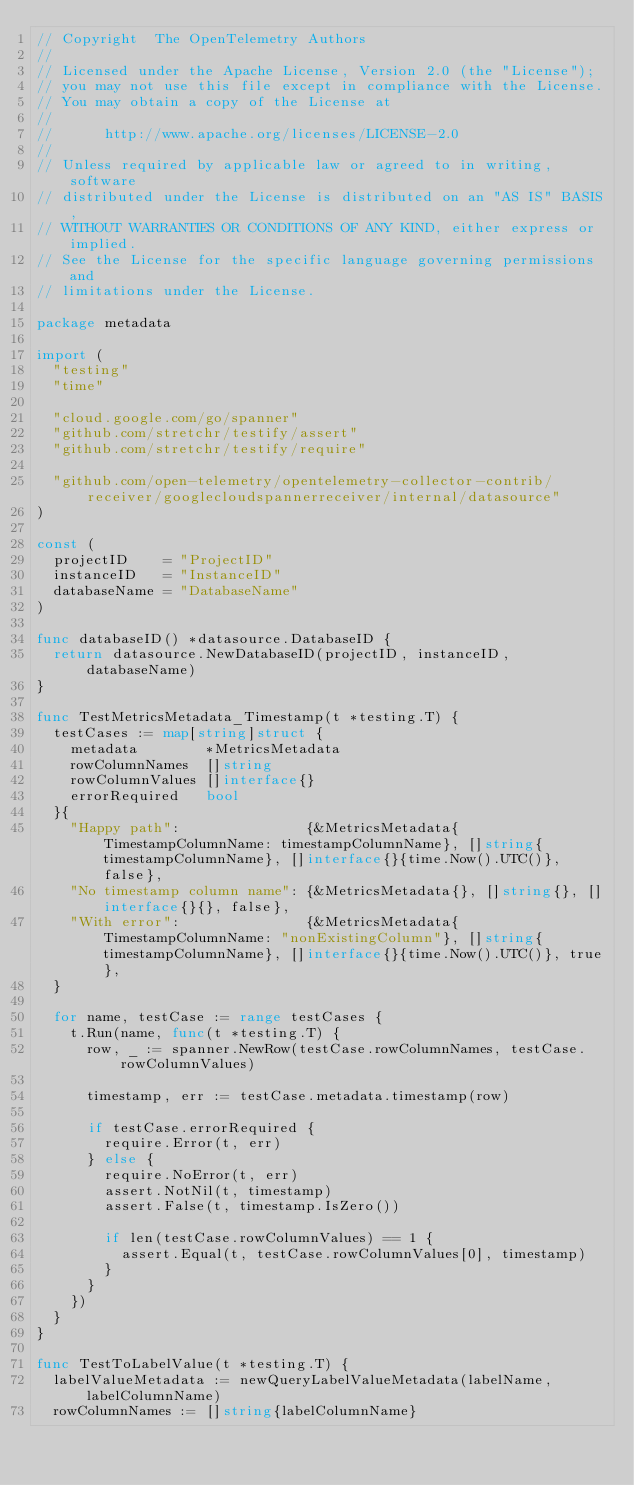<code> <loc_0><loc_0><loc_500><loc_500><_Go_>// Copyright  The OpenTelemetry Authors
//
// Licensed under the Apache License, Version 2.0 (the "License");
// you may not use this file except in compliance with the License.
// You may obtain a copy of the License at
//
//      http://www.apache.org/licenses/LICENSE-2.0
//
// Unless required by applicable law or agreed to in writing, software
// distributed under the License is distributed on an "AS IS" BASIS,
// WITHOUT WARRANTIES OR CONDITIONS OF ANY KIND, either express or implied.
// See the License for the specific language governing permissions and
// limitations under the License.

package metadata

import (
	"testing"
	"time"

	"cloud.google.com/go/spanner"
	"github.com/stretchr/testify/assert"
	"github.com/stretchr/testify/require"

	"github.com/open-telemetry/opentelemetry-collector-contrib/receiver/googlecloudspannerreceiver/internal/datasource"
)

const (
	projectID    = "ProjectID"
	instanceID   = "InstanceID"
	databaseName = "DatabaseName"
)

func databaseID() *datasource.DatabaseID {
	return datasource.NewDatabaseID(projectID, instanceID, databaseName)
}

func TestMetricsMetadata_Timestamp(t *testing.T) {
	testCases := map[string]struct {
		metadata        *MetricsMetadata
		rowColumnNames  []string
		rowColumnValues []interface{}
		errorRequired   bool
	}{
		"Happy path":               {&MetricsMetadata{TimestampColumnName: timestampColumnName}, []string{timestampColumnName}, []interface{}{time.Now().UTC()}, false},
		"No timestamp column name": {&MetricsMetadata{}, []string{}, []interface{}{}, false},
		"With error":               {&MetricsMetadata{TimestampColumnName: "nonExistingColumn"}, []string{timestampColumnName}, []interface{}{time.Now().UTC()}, true},
	}

	for name, testCase := range testCases {
		t.Run(name, func(t *testing.T) {
			row, _ := spanner.NewRow(testCase.rowColumnNames, testCase.rowColumnValues)

			timestamp, err := testCase.metadata.timestamp(row)

			if testCase.errorRequired {
				require.Error(t, err)
			} else {
				require.NoError(t, err)
				assert.NotNil(t, timestamp)
				assert.False(t, timestamp.IsZero())

				if len(testCase.rowColumnValues) == 1 {
					assert.Equal(t, testCase.rowColumnValues[0], timestamp)
				}
			}
		})
	}
}

func TestToLabelValue(t *testing.T) {
	labelValueMetadata := newQueryLabelValueMetadata(labelName, labelColumnName)
	rowColumnNames := []string{labelColumnName}</code> 